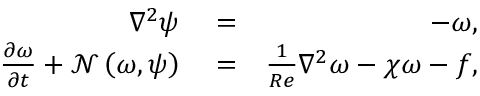<formula> <loc_0><loc_0><loc_500><loc_500>\begin{array} { r l r } { \nabla ^ { 2 } \psi } & = } & { - \omega , } \\ { \frac { \partial \omega } { \partial t } + \mathcal { N } \left ( \omega , \psi \right ) } & = } & { \frac { 1 } { R e } \nabla ^ { 2 } \omega - \chi \omega - f , } \end{array}</formula> 